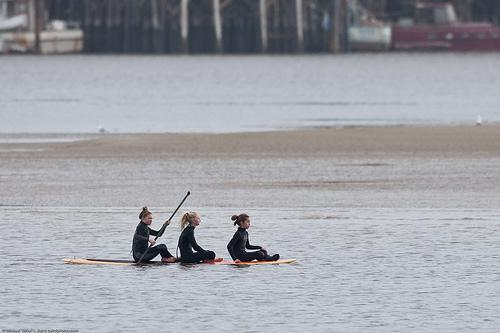Question: who is on the surfboard?
Choices:
A. Young boy.
B. Young lady.
C. Women.
D. Man.
Answer with the letter. Answer: C Question: how many birds are in the photo?
Choices:
A. 5.
B. 2.
C. 3.
D. 9.
Answer with the letter. Answer: B Question: how many women are on the surfboard?
Choices:
A. 2.
B. 8.
C. 3.
D. 6.
Answer with the letter. Answer: C Question: what are the woman riding on?
Choices:
A. Horses.
B. Scooters.
C. Surfboard.
D. Snowmobiles.
Answer with the letter. Answer: C 